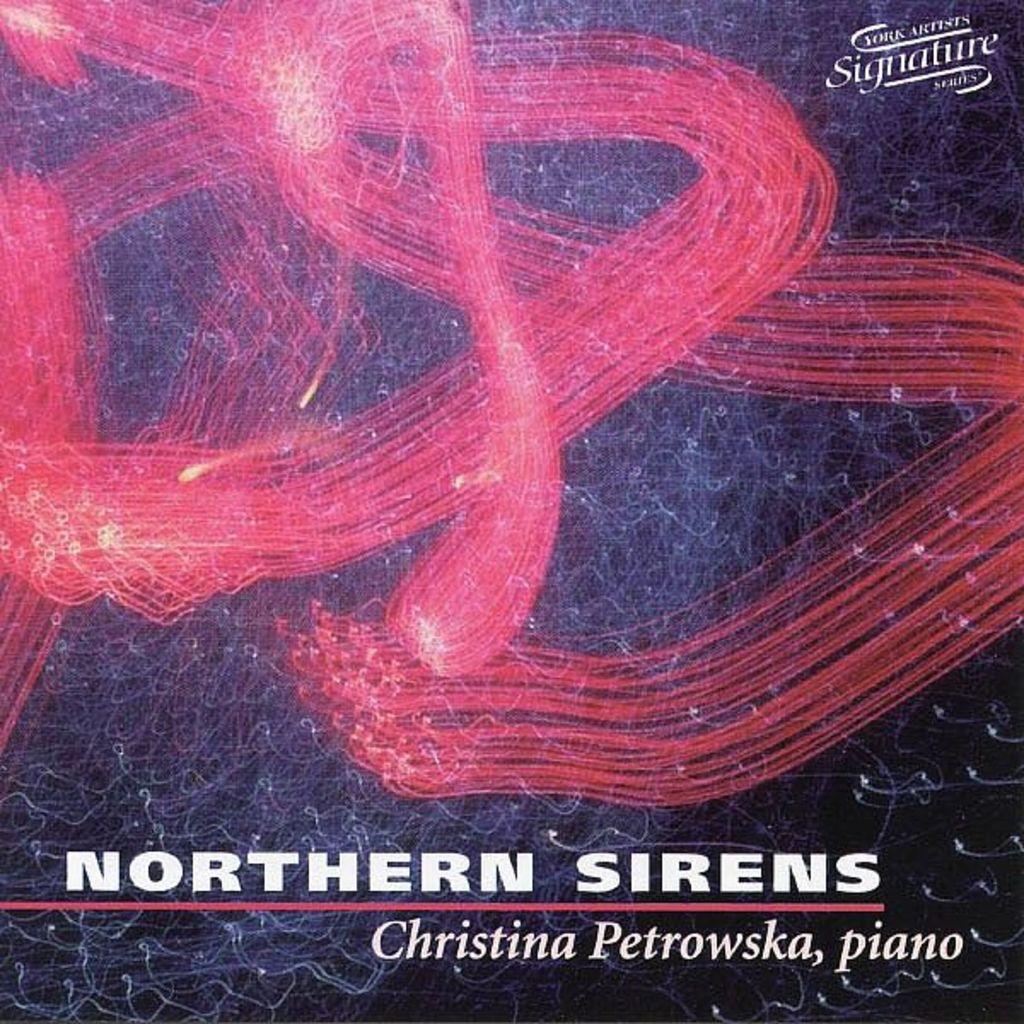Who is the artist being featured?
Give a very brief answer. Christina petrowska. What instrument is listed?
Provide a succinct answer. Piano. 